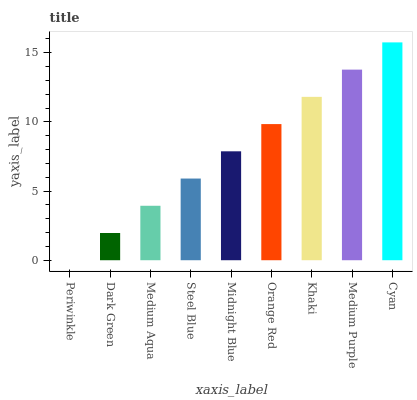Is Periwinkle the minimum?
Answer yes or no. Yes. Is Cyan the maximum?
Answer yes or no. Yes. Is Dark Green the minimum?
Answer yes or no. No. Is Dark Green the maximum?
Answer yes or no. No. Is Dark Green greater than Periwinkle?
Answer yes or no. Yes. Is Periwinkle less than Dark Green?
Answer yes or no. Yes. Is Periwinkle greater than Dark Green?
Answer yes or no. No. Is Dark Green less than Periwinkle?
Answer yes or no. No. Is Midnight Blue the high median?
Answer yes or no. Yes. Is Midnight Blue the low median?
Answer yes or no. Yes. Is Steel Blue the high median?
Answer yes or no. No. Is Medium Aqua the low median?
Answer yes or no. No. 